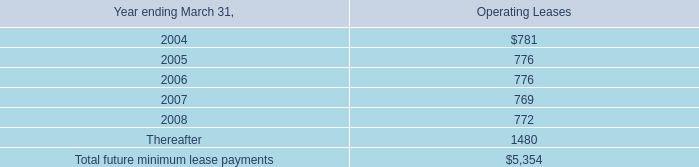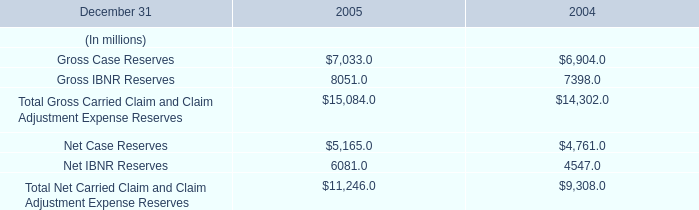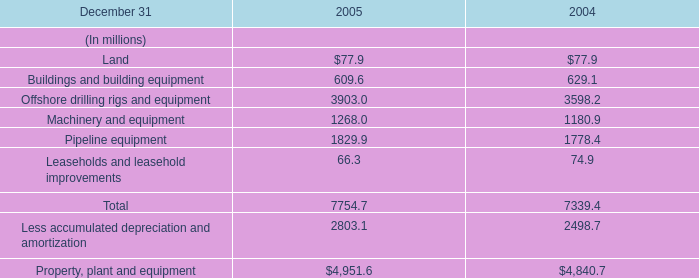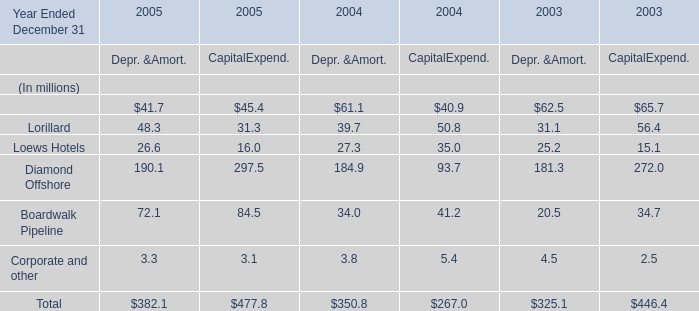If Pipeline equipment develops with the same increasing rate in 2005, what will it reach in 2006? (in million) 
Computations: ((((1829.9 - 1778.4) / 1778.4) + 1) * 1829.9)
Answer: 1882.89137. 